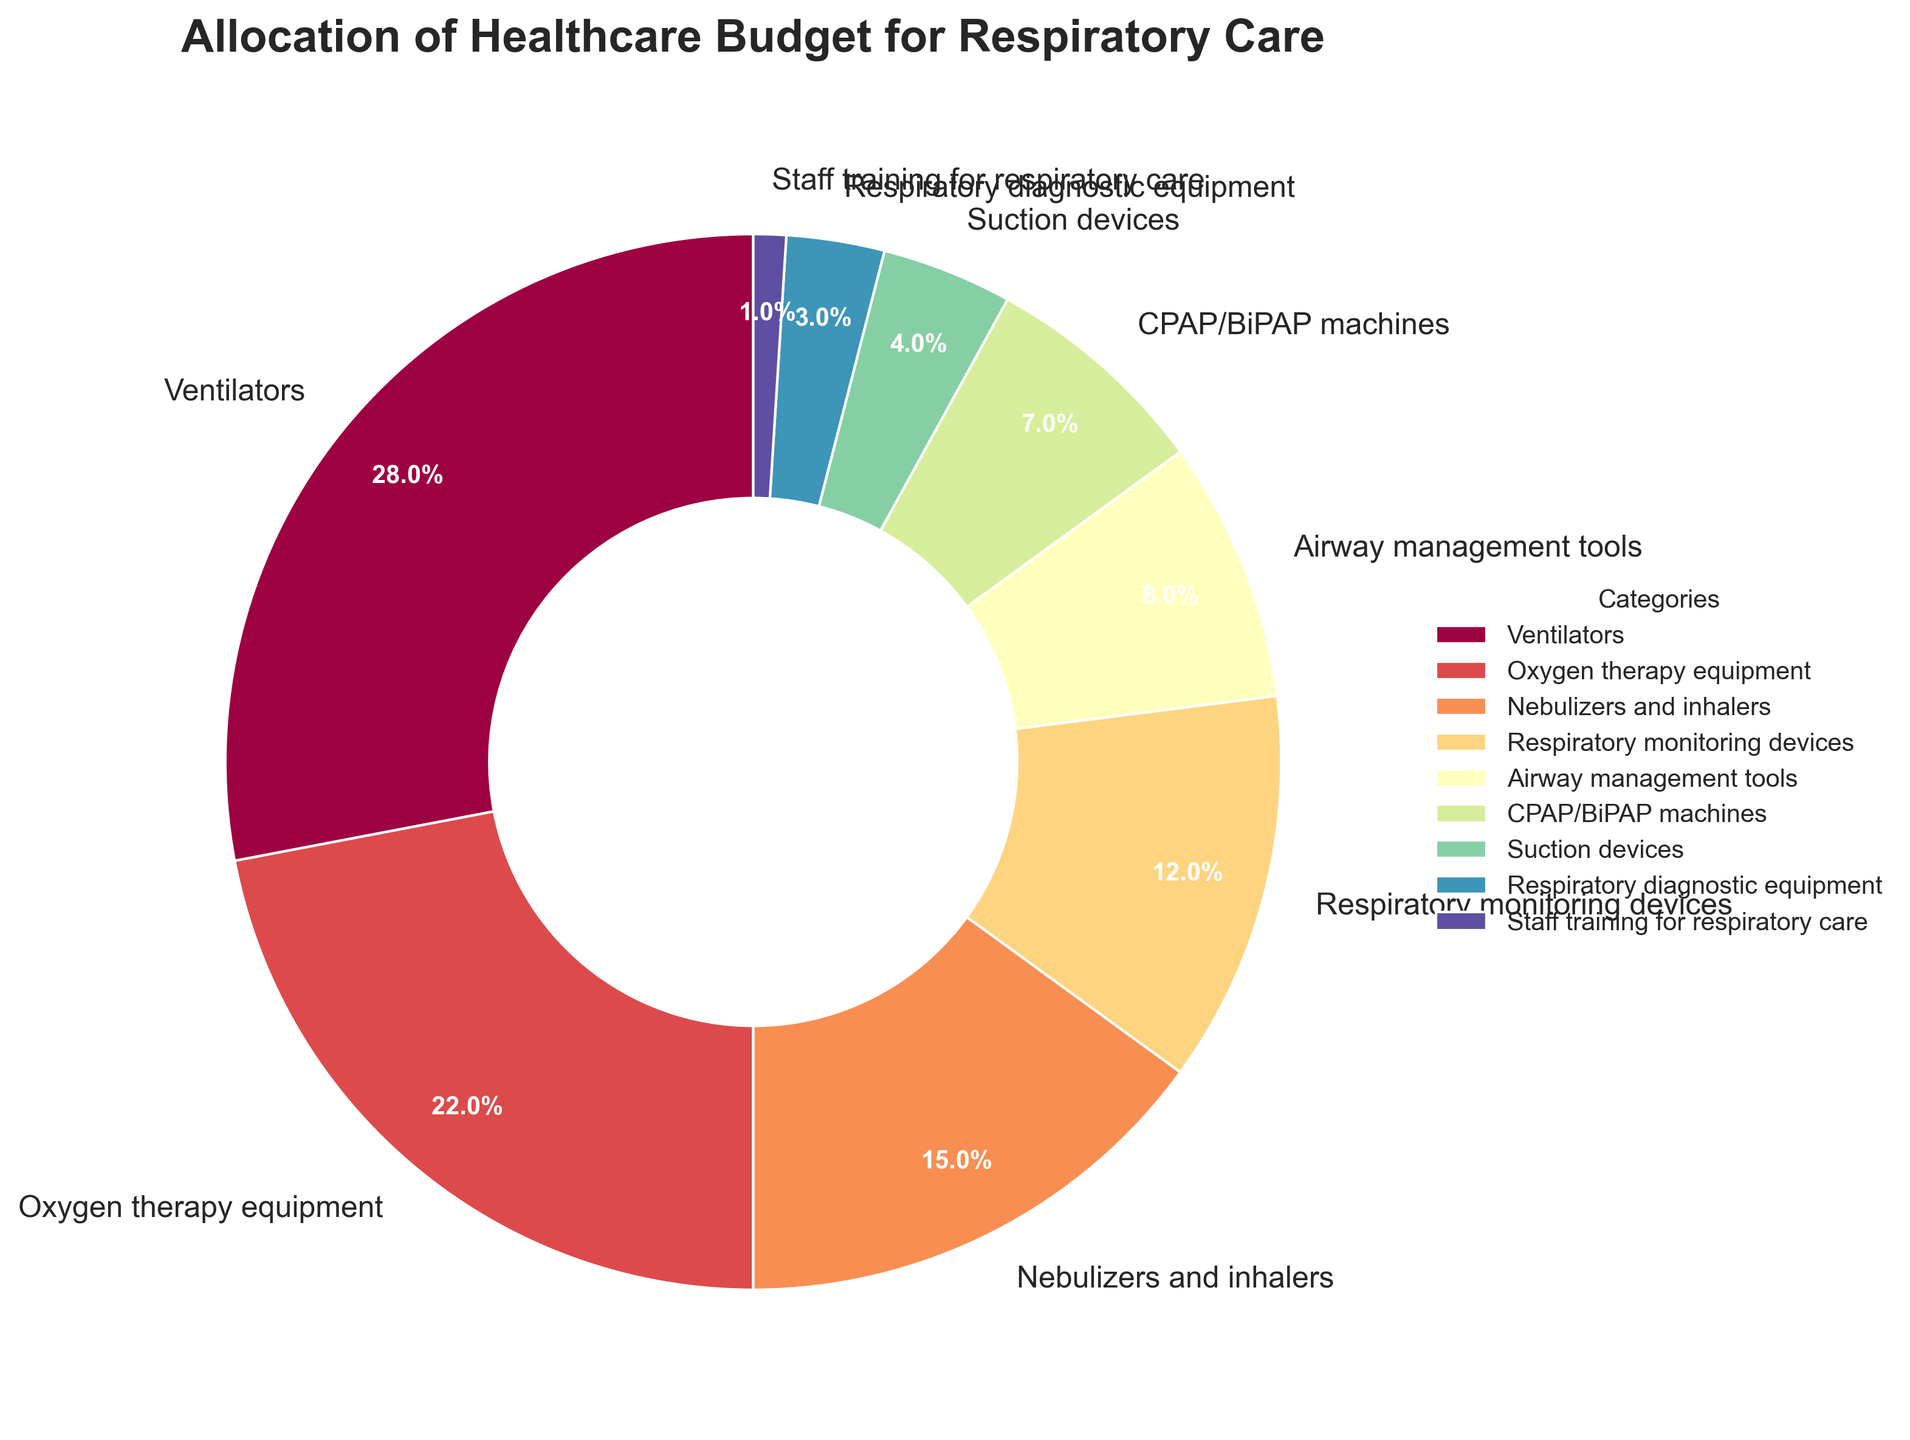Which category receives the largest allocation of the healthcare budget? The pie chart depicts the allocation percentages, and the "Ventilators" category has the largest wedge.
Answer: Ventilators What's the combined budget allocation for Oxygen therapy equipment and Respiratory monitoring devices? Adding the percentages for "Oxygen therapy equipment" (22%) and "Respiratory monitoring devices" (12%) gives 22% + 12%.
Answer: 34% How much less is allocated to CPAP/BiPAP machines compared to Nebulizers and inhalers? Compare the percentages: CPAP/BiPAP machines (7%) and Nebulizers and inhalers (15%). The difference is 15% - 7%.
Answer: 8% Which categories together form more than 50% of the budget allocation? Summing the largest percentages sequentially until the total exceeds 50%: Ventilators (28%) + Oxygen therapy equipment (22%) = 50%.
Answer: Ventilators and Oxygen therapy equipment What is the visual representation color of the category with the lowest budget allocation? Observing the color coding in the pie chart, "Staff training for respiratory care" (1%) is represented by the smallest wedge. The color of this wedge needs to be identified by looking at the chart.
Answer: [The specific color in the chart] How much more is allocated to Airway management tools than to Suction devices? Compare "Airway management tools" (8%) with "Suction devices" (4%). The difference is 8% - 4%.
Answer: 4% What is the average budget allocation across all categories? Sum all percentages (28 + 22 + 15 + 12 + 8 + 7 + 4 + 3 + 1 = 100). Divide by the number of categories (9).
Answer: 11.11% Which category has an allocation percentage closest to the average allocation across all categories? The average allocation is 11.11%. The categories close to this are "Respiratory monitoring devices" (12%) and "Airway management tools" (8%), but "Respiratory monitoring devices" is closer.
Answer: Respiratory monitoring devices What's the difference in budget allocation between the largest and smallest allocation categories? The "Ventilators" category gets 28%, and "Staff training for respiratory care" gets 1%. The difference is 28% - 1%.
Answer: 27% What percentage of the budget is allocated to Nebulizers and inhalers relative to the total budget for Respiratory diagnostic equipment and Suction devices? "Nebulizers and inhalers" is 15%. "Respiratory diagnostic equipment" is 3%, and "Suction devices" is 4%. Total for the latter two is 3% + 4% = 7%. The relative percentage is 15% / 7%.
Answer: Roughly 214% 